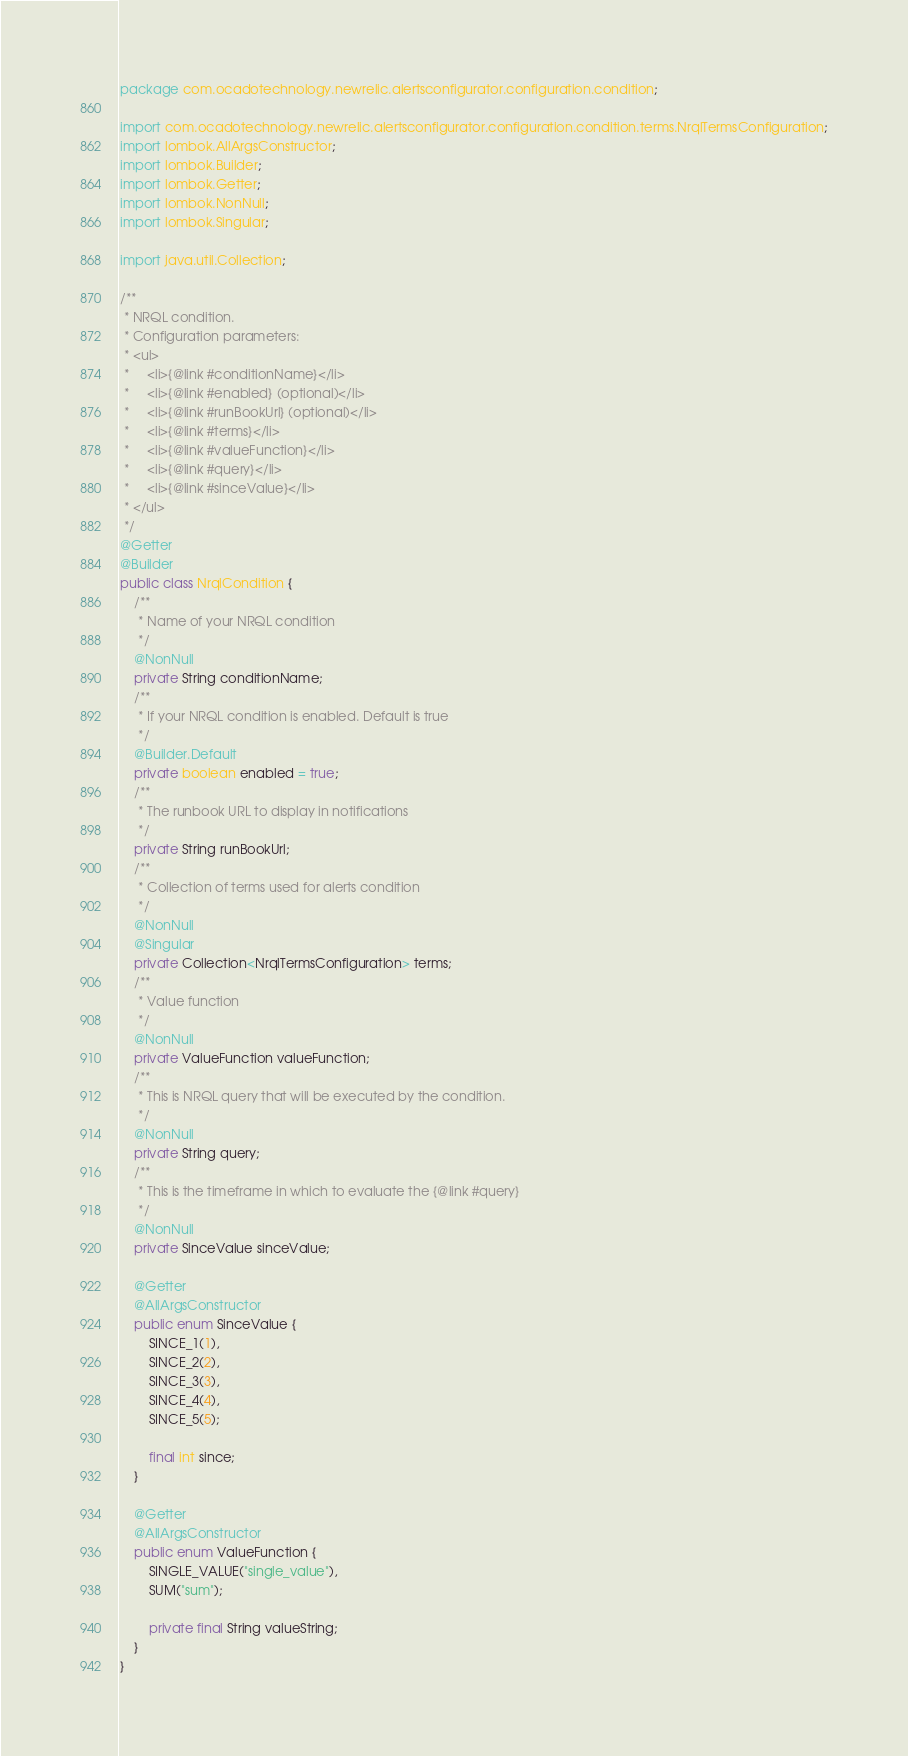<code> <loc_0><loc_0><loc_500><loc_500><_Java_>package com.ocadotechnology.newrelic.alertsconfigurator.configuration.condition;

import com.ocadotechnology.newrelic.alertsconfigurator.configuration.condition.terms.NrqlTermsConfiguration;
import lombok.AllArgsConstructor;
import lombok.Builder;
import lombok.Getter;
import lombok.NonNull;
import lombok.Singular;

import java.util.Collection;

/**
 * NRQL condition.
 * Configuration parameters:
 * <ul>
 *     <li>{@link #conditionName}</li>
 *     <li>{@link #enabled} (optional)</li>
 *     <li>{@link #runBookUrl} (optional)</li>
 *     <li>{@link #terms}</li>
 *     <li>{@link #valueFunction}</li>
 *     <li>{@link #query}</li>
 *     <li>{@link #sinceValue}</li>
 * </ul>
 */
@Getter
@Builder
public class NrqlCondition {
    /**
     * Name of your NRQL condition
     */
    @NonNull
    private String conditionName;
    /**
     * If your NRQL condition is enabled. Default is true
     */
    @Builder.Default
    private boolean enabled = true;
    /**
     * The runbook URL to display in notifications
     */
    private String runBookUrl;
    /**
     * Collection of terms used for alerts condition
     */
    @NonNull
    @Singular
    private Collection<NrqlTermsConfiguration> terms;
    /**
     * Value function
     */
    @NonNull
    private ValueFunction valueFunction;
    /**
     * This is NRQL query that will be executed by the condition.
     */
    @NonNull
    private String query;
    /**
     * This is the timeframe in which to evaluate the {@link #query}
     */
    @NonNull
    private SinceValue sinceValue;

    @Getter
    @AllArgsConstructor
    public enum SinceValue {
        SINCE_1(1),
        SINCE_2(2),
        SINCE_3(3),
        SINCE_4(4),
        SINCE_5(5);

        final int since;
    }

    @Getter
    @AllArgsConstructor
    public enum ValueFunction {
        SINGLE_VALUE("single_value"),
        SUM("sum");

        private final String valueString;
    }
}
</code> 